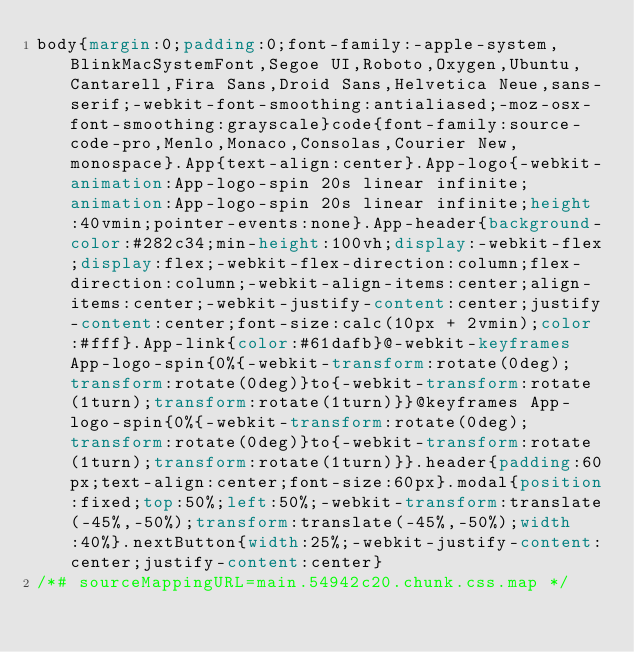<code> <loc_0><loc_0><loc_500><loc_500><_CSS_>body{margin:0;padding:0;font-family:-apple-system,BlinkMacSystemFont,Segoe UI,Roboto,Oxygen,Ubuntu,Cantarell,Fira Sans,Droid Sans,Helvetica Neue,sans-serif;-webkit-font-smoothing:antialiased;-moz-osx-font-smoothing:grayscale}code{font-family:source-code-pro,Menlo,Monaco,Consolas,Courier New,monospace}.App{text-align:center}.App-logo{-webkit-animation:App-logo-spin 20s linear infinite;animation:App-logo-spin 20s linear infinite;height:40vmin;pointer-events:none}.App-header{background-color:#282c34;min-height:100vh;display:-webkit-flex;display:flex;-webkit-flex-direction:column;flex-direction:column;-webkit-align-items:center;align-items:center;-webkit-justify-content:center;justify-content:center;font-size:calc(10px + 2vmin);color:#fff}.App-link{color:#61dafb}@-webkit-keyframes App-logo-spin{0%{-webkit-transform:rotate(0deg);transform:rotate(0deg)}to{-webkit-transform:rotate(1turn);transform:rotate(1turn)}}@keyframes App-logo-spin{0%{-webkit-transform:rotate(0deg);transform:rotate(0deg)}to{-webkit-transform:rotate(1turn);transform:rotate(1turn)}}.header{padding:60px;text-align:center;font-size:60px}.modal{position:fixed;top:50%;left:50%;-webkit-transform:translate(-45%,-50%);transform:translate(-45%,-50%);width:40%}.nextButton{width:25%;-webkit-justify-content:center;justify-content:center}
/*# sourceMappingURL=main.54942c20.chunk.css.map */</code> 